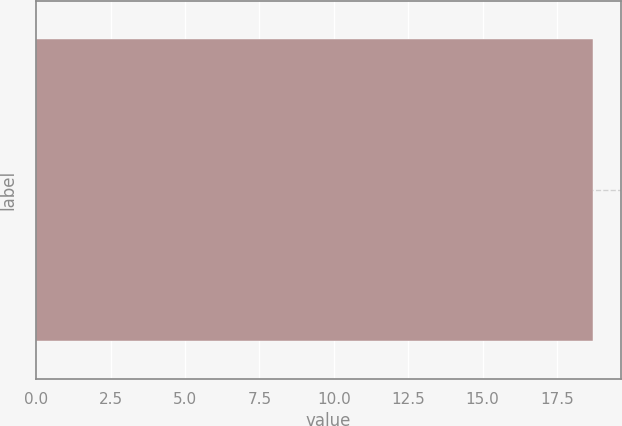Convert chart to OTSL. <chart><loc_0><loc_0><loc_500><loc_500><bar_chart><ecel><nl><fcel>18.72<nl></chart> 